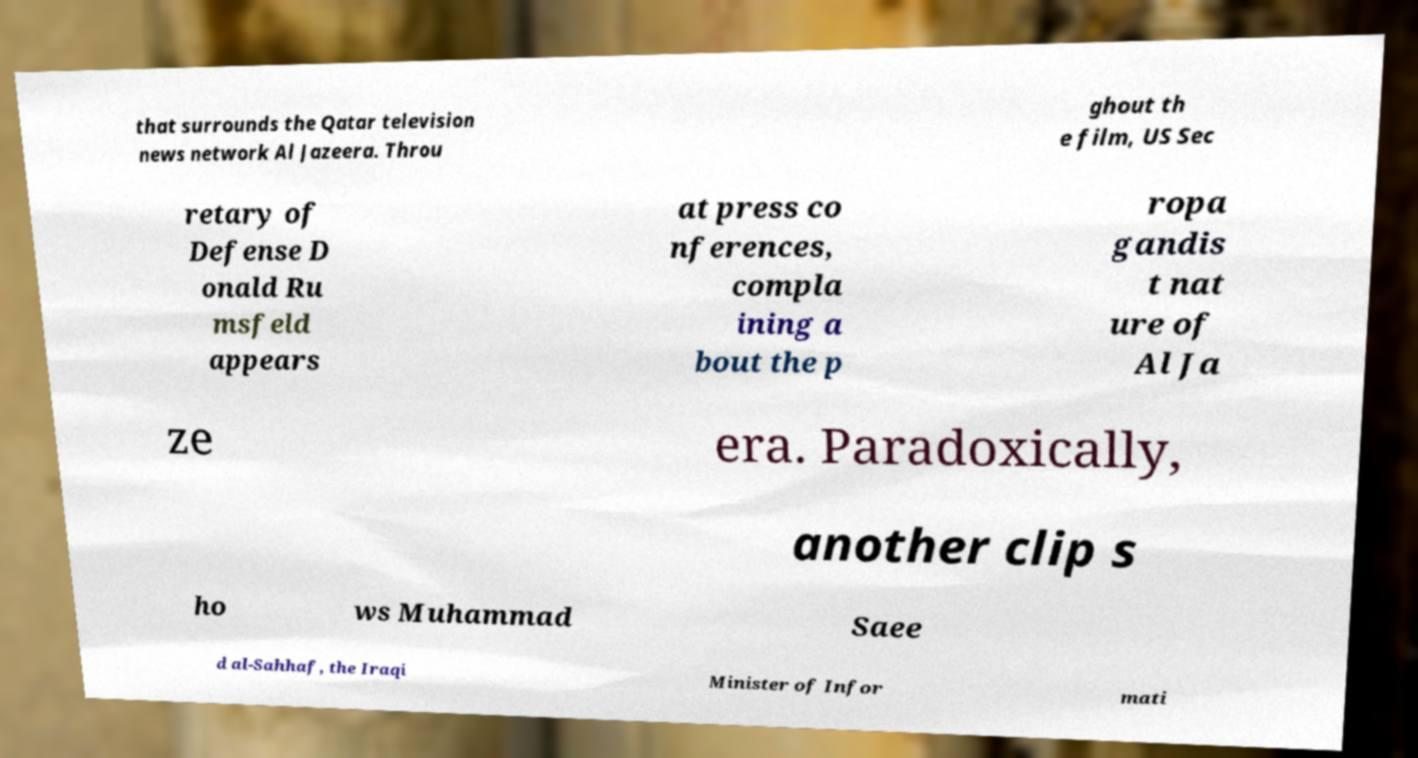Please identify and transcribe the text found in this image. that surrounds the Qatar television news network Al Jazeera. Throu ghout th e film, US Sec retary of Defense D onald Ru msfeld appears at press co nferences, compla ining a bout the p ropa gandis t nat ure of Al Ja ze era. Paradoxically, another clip s ho ws Muhammad Saee d al-Sahhaf, the Iraqi Minister of Infor mati 